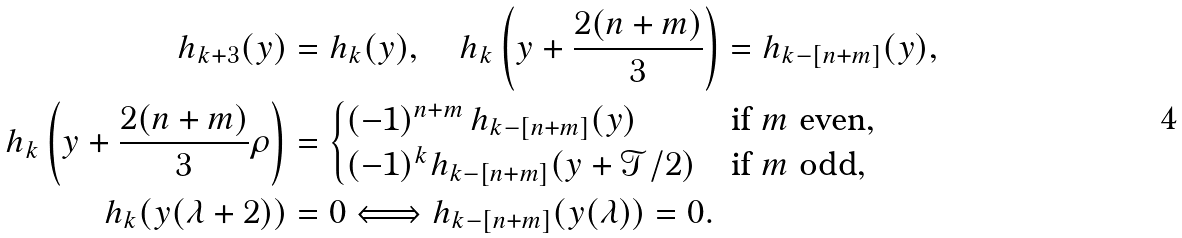<formula> <loc_0><loc_0><loc_500><loc_500>h _ { k + 3 } ( y ) & = h _ { k } ( y ) , \quad h _ { k } \left ( y + \frac { 2 ( n + m ) } 3 \right ) = h _ { k - [ n + m ] } ( y ) , \\ h _ { k } \left ( y + \frac { 2 ( n + m ) } 3 \rho \right ) & = \begin{cases} ( - 1 ) ^ { n + m } \, h _ { k - [ n + m ] } ( y ) & \text {if } m \text { even} , \\ ( - 1 ) ^ { k } h _ { k - [ n + m ] } ( y + \mathcal { T } / 2 ) & \text {if } m \text { odd} , \end{cases} \\ h _ { k } ( y ( \lambda + 2 ) ) & = 0 \Longleftrightarrow h _ { k - [ n + m ] } ( y ( \lambda ) ) = 0 .</formula> 